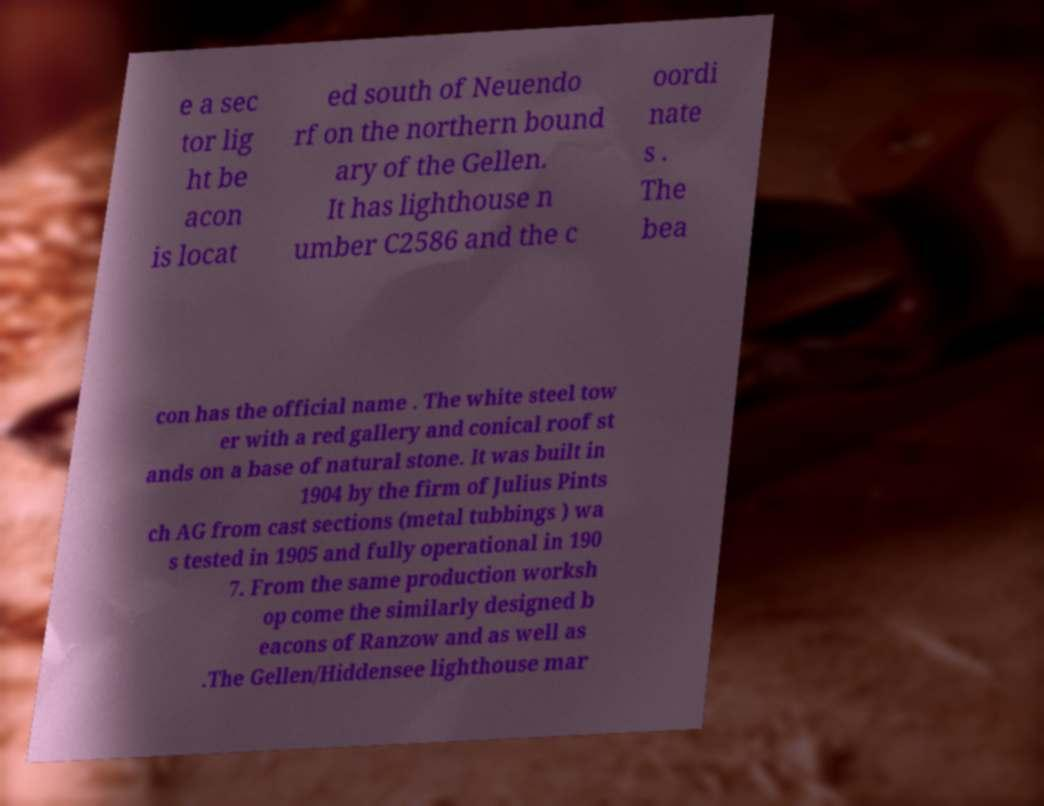Can you accurately transcribe the text from the provided image for me? e a sec tor lig ht be acon is locat ed south of Neuendo rf on the northern bound ary of the Gellen. It has lighthouse n umber C2586 and the c oordi nate s . The bea con has the official name . The white steel tow er with a red gallery and conical roof st ands on a base of natural stone. It was built in 1904 by the firm of Julius Pints ch AG from cast sections (metal tubbings ) wa s tested in 1905 and fully operational in 190 7. From the same production worksh op come the similarly designed b eacons of Ranzow and as well as .The Gellen/Hiddensee lighthouse mar 